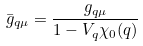<formula> <loc_0><loc_0><loc_500><loc_500>\bar { g } _ { q \mu } = \frac { g _ { q \mu } } { 1 - V _ { q } \chi _ { 0 } ( q ) }</formula> 